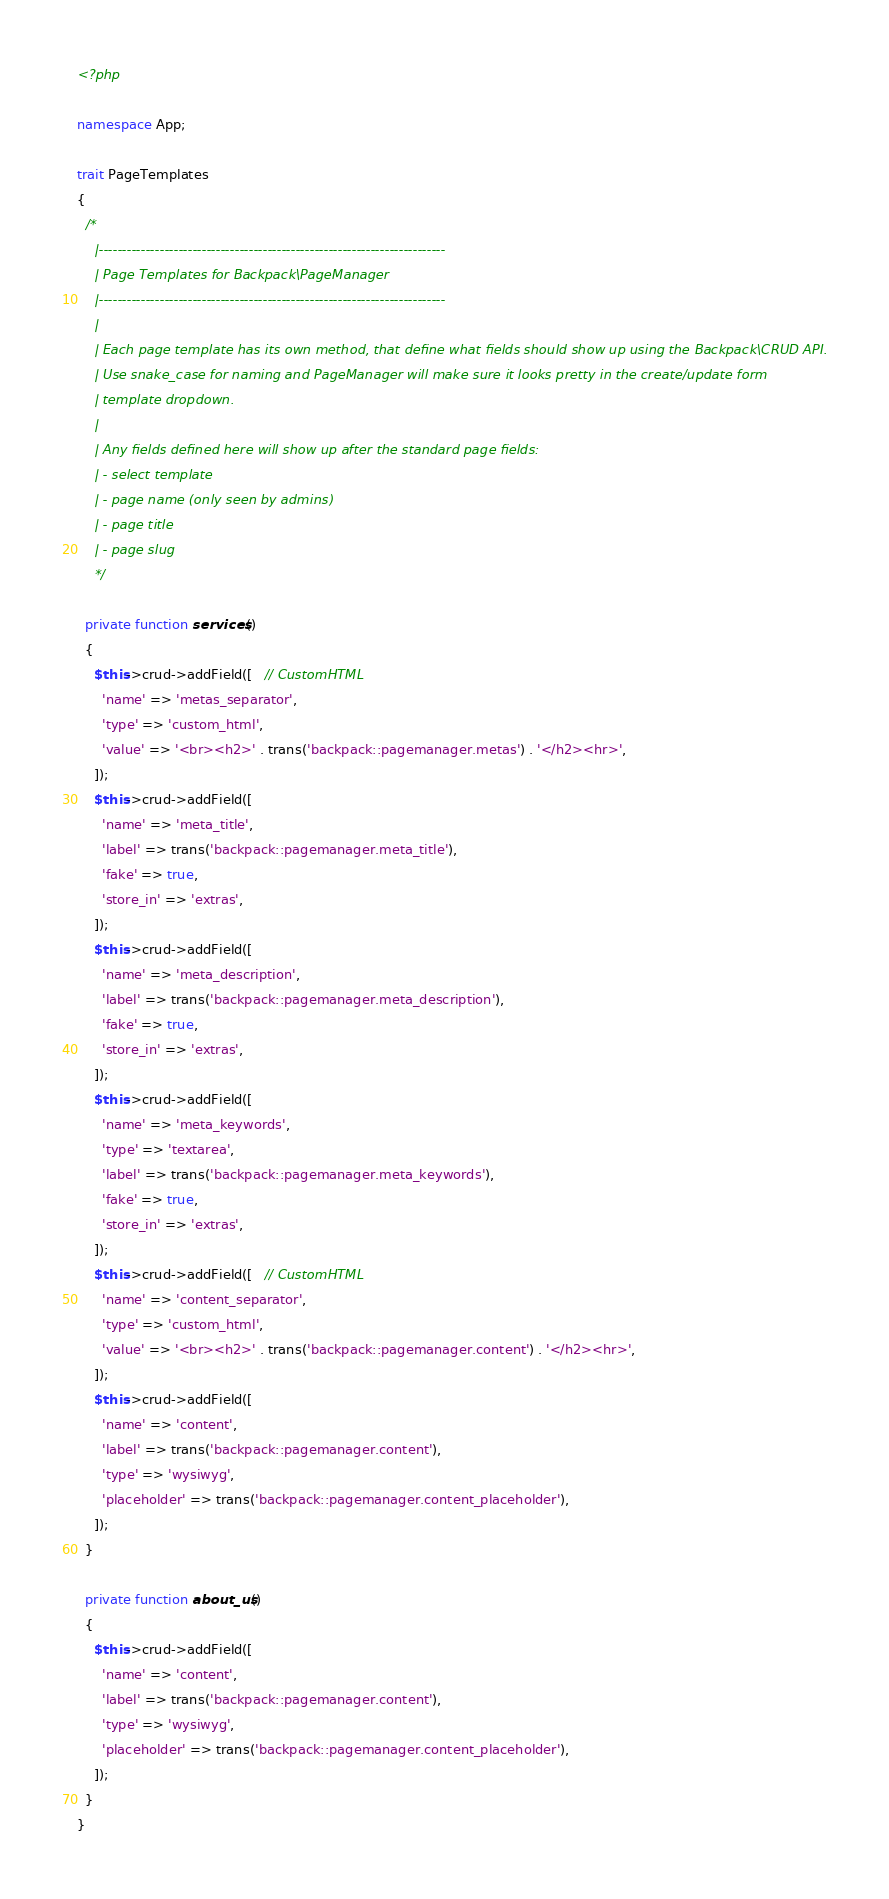<code> <loc_0><loc_0><loc_500><loc_500><_PHP_><?php

namespace App;

trait PageTemplates
{
  /*
    |--------------------------------------------------------------------------
    | Page Templates for Backpack\PageManager
    |--------------------------------------------------------------------------
    |
    | Each page template has its own method, that define what fields should show up using the Backpack\CRUD API.
    | Use snake_case for naming and PageManager will make sure it looks pretty in the create/update form
    | template dropdown.
    |
    | Any fields defined here will show up after the standard page fields:
    | - select template
    | - page name (only seen by admins)
    | - page title
    | - page slug
    */

  private function services()
  {
    $this->crud->addField([   // CustomHTML
      'name' => 'metas_separator',
      'type' => 'custom_html',
      'value' => '<br><h2>' . trans('backpack::pagemanager.metas') . '</h2><hr>',
    ]);
    $this->crud->addField([
      'name' => 'meta_title',
      'label' => trans('backpack::pagemanager.meta_title'),
      'fake' => true,
      'store_in' => 'extras',
    ]);
    $this->crud->addField([
      'name' => 'meta_description',
      'label' => trans('backpack::pagemanager.meta_description'),
      'fake' => true,
      'store_in' => 'extras',
    ]);
    $this->crud->addField([
      'name' => 'meta_keywords',
      'type' => 'textarea',
      'label' => trans('backpack::pagemanager.meta_keywords'),
      'fake' => true,
      'store_in' => 'extras',
    ]);
    $this->crud->addField([   // CustomHTML
      'name' => 'content_separator',
      'type' => 'custom_html',
      'value' => '<br><h2>' . trans('backpack::pagemanager.content') . '</h2><hr>',
    ]);
    $this->crud->addField([
      'name' => 'content',
      'label' => trans('backpack::pagemanager.content'),
      'type' => 'wysiwyg',
      'placeholder' => trans('backpack::pagemanager.content_placeholder'),
    ]);
  }

  private function about_us()
  {
    $this->crud->addField([
      'name' => 'content',
      'label' => trans('backpack::pagemanager.content'),
      'type' => 'wysiwyg',
      'placeholder' => trans('backpack::pagemanager.content_placeholder'),
    ]);
  }
}
</code> 